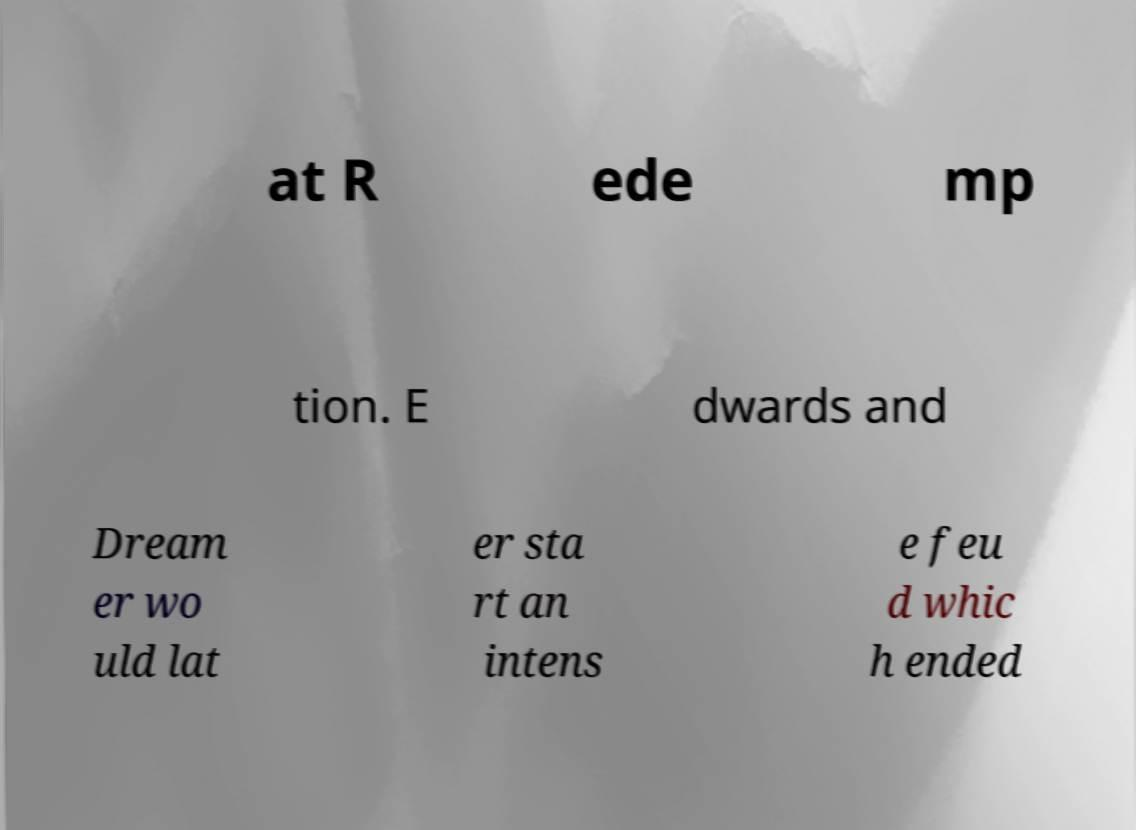For documentation purposes, I need the text within this image transcribed. Could you provide that? at R ede mp tion. E dwards and Dream er wo uld lat er sta rt an intens e feu d whic h ended 